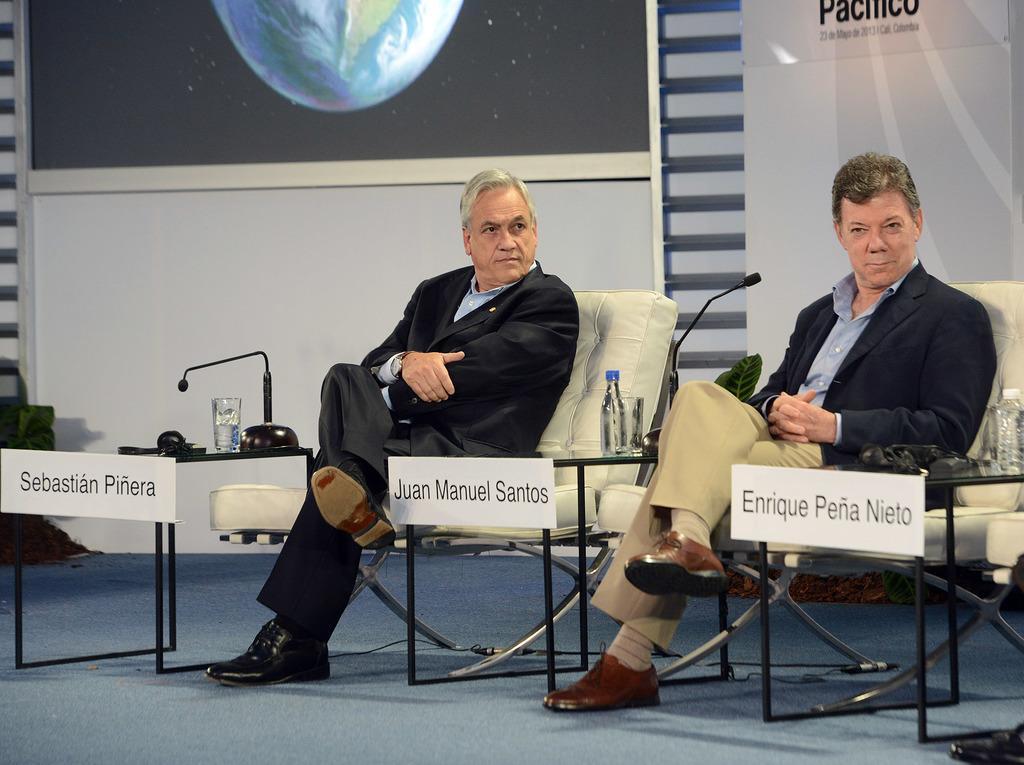Describe this image in one or two sentences. In this image there are two persons sitting on the chair, there is a water bottle on the table, there is a microphone on the table, there is a glass on the table, there are objects on the table, there is text on the board, there is a screen truncated, there is a wall behind the person, there is a board truncated towards the right of the image, there is a water bottle truncated towards the right of the image, there is a shoe truncated towards the right of the image. 